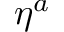Convert formula to latex. <formula><loc_0><loc_0><loc_500><loc_500>\eta ^ { a }</formula> 